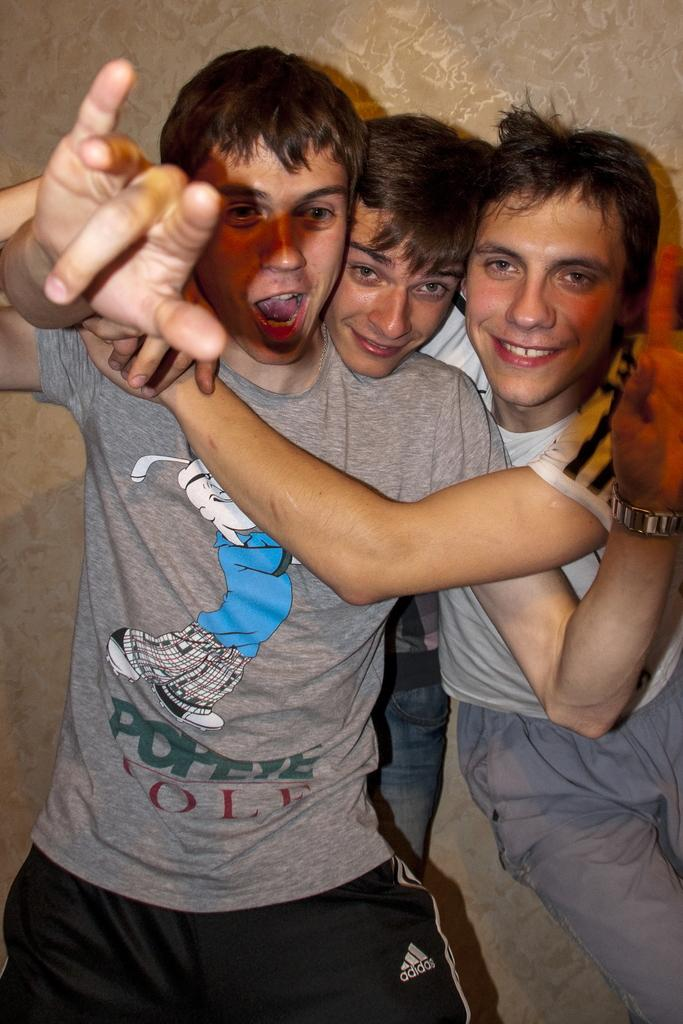<image>
Describe the image concisely. a shirt that has the name popeye on it 